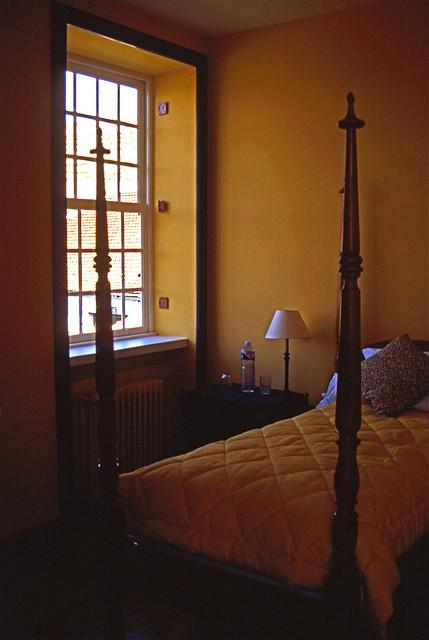What is the tip of the bed structures called?

Choices:
A) pillows
B) finials
C) mattress
D) headrest finials 